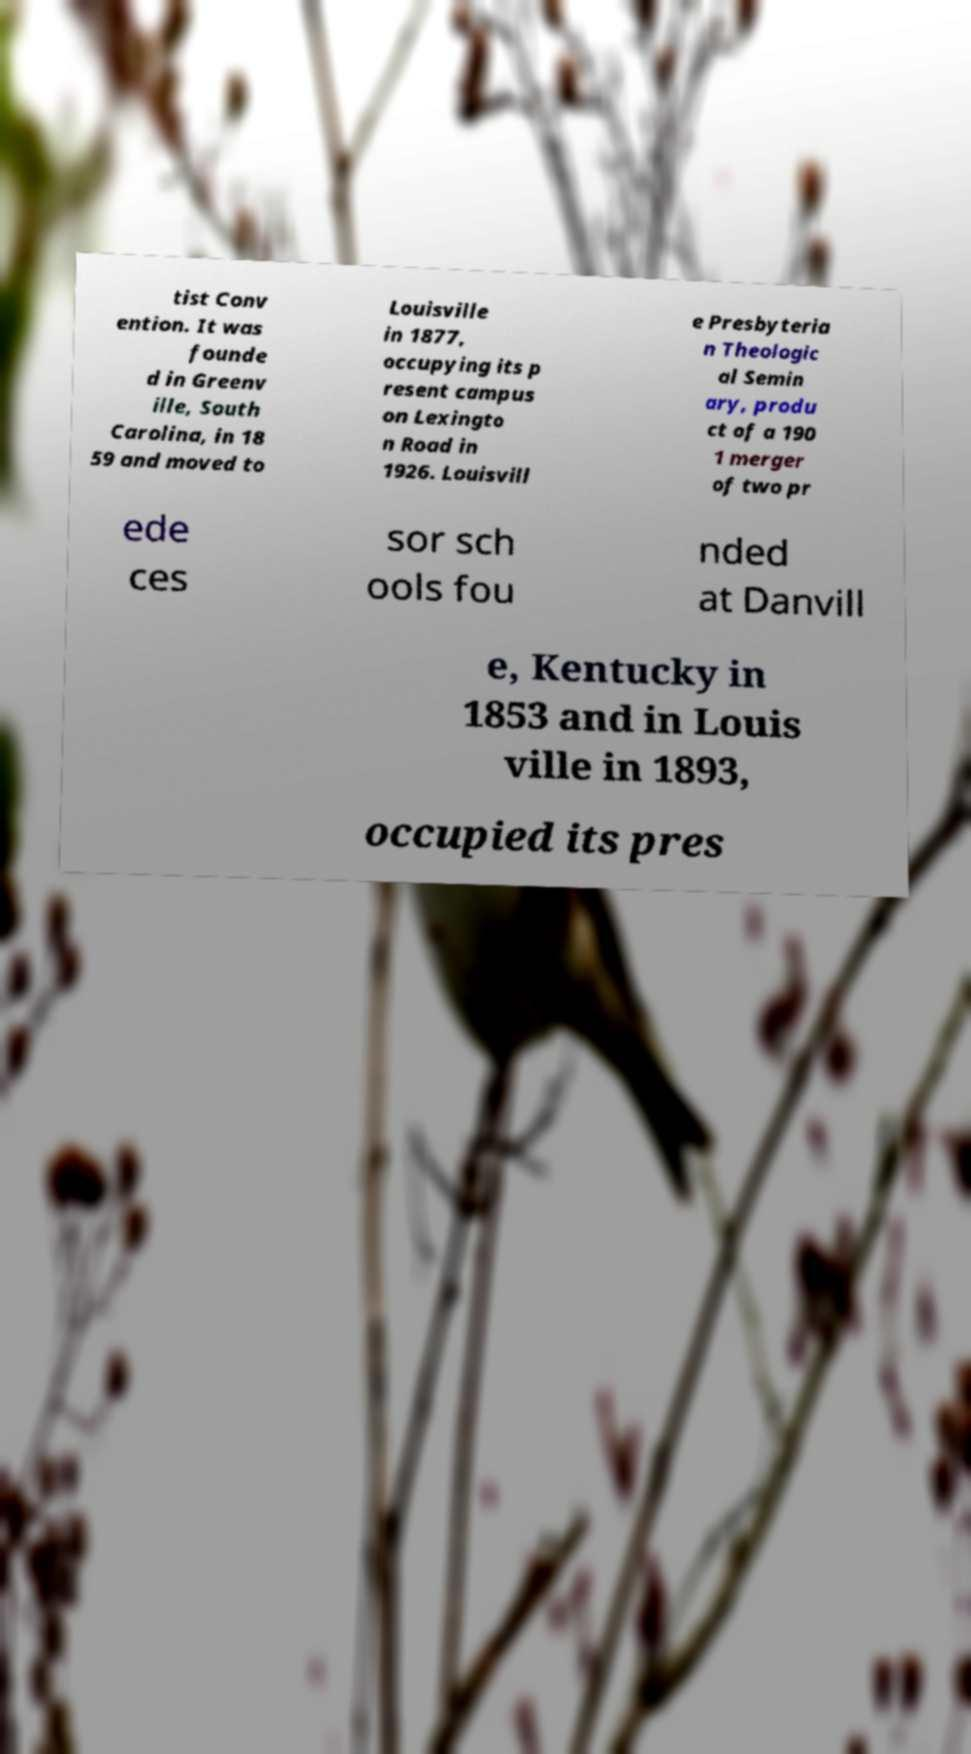What messages or text are displayed in this image? I need them in a readable, typed format. tist Conv ention. It was founde d in Greenv ille, South Carolina, in 18 59 and moved to Louisville in 1877, occupying its p resent campus on Lexingto n Road in 1926. Louisvill e Presbyteria n Theologic al Semin ary, produ ct of a 190 1 merger of two pr ede ces sor sch ools fou nded at Danvill e, Kentucky in 1853 and in Louis ville in 1893, occupied its pres 